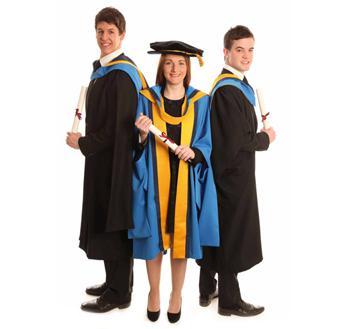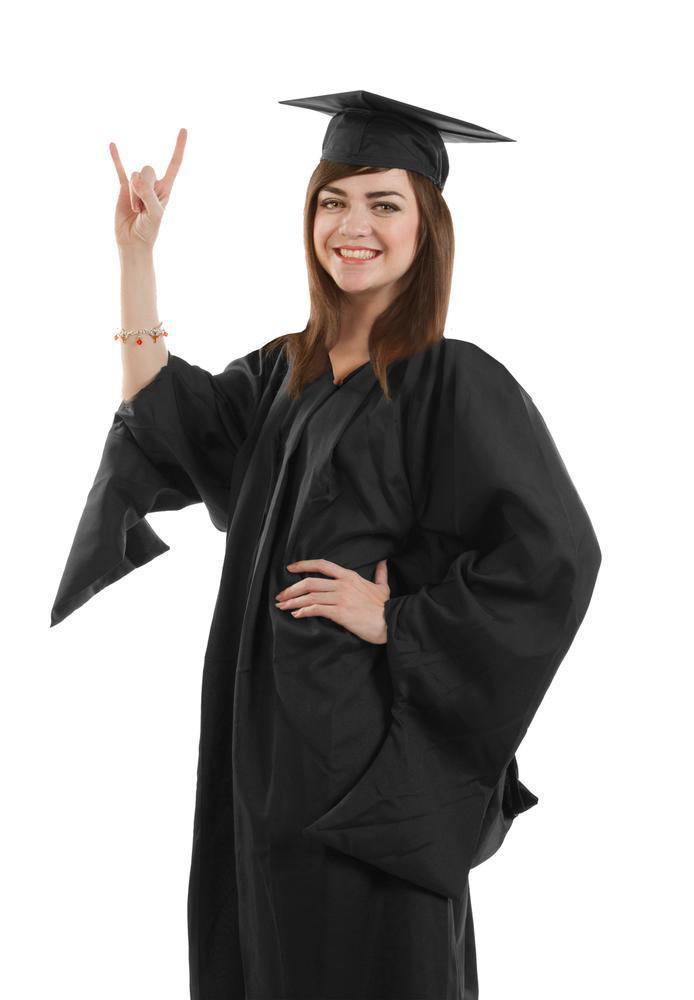The first image is the image on the left, the second image is the image on the right. For the images shown, is this caption "THere are exactly two people in the image on the left." true? Answer yes or no. No. 